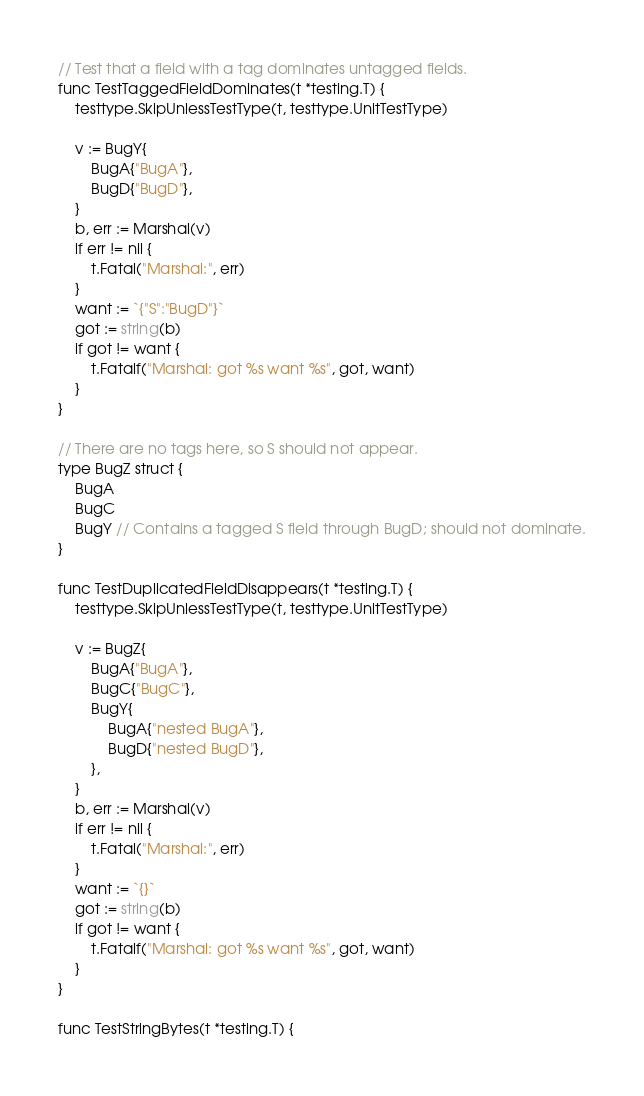<code> <loc_0><loc_0><loc_500><loc_500><_Go_>// Test that a field with a tag dominates untagged fields.
func TestTaggedFieldDominates(t *testing.T) {
	testtype.SkipUnlessTestType(t, testtype.UnitTestType)

	v := BugY{
		BugA{"BugA"},
		BugD{"BugD"},
	}
	b, err := Marshal(v)
	if err != nil {
		t.Fatal("Marshal:", err)
	}
	want := `{"S":"BugD"}`
	got := string(b)
	if got != want {
		t.Fatalf("Marshal: got %s want %s", got, want)
	}
}

// There are no tags here, so S should not appear.
type BugZ struct {
	BugA
	BugC
	BugY // Contains a tagged S field through BugD; should not dominate.
}

func TestDuplicatedFieldDisappears(t *testing.T) {
	testtype.SkipUnlessTestType(t, testtype.UnitTestType)

	v := BugZ{
		BugA{"BugA"},
		BugC{"BugC"},
		BugY{
			BugA{"nested BugA"},
			BugD{"nested BugD"},
		},
	}
	b, err := Marshal(v)
	if err != nil {
		t.Fatal("Marshal:", err)
	}
	want := `{}`
	got := string(b)
	if got != want {
		t.Fatalf("Marshal: got %s want %s", got, want)
	}
}

func TestStringBytes(t *testing.T) {</code> 